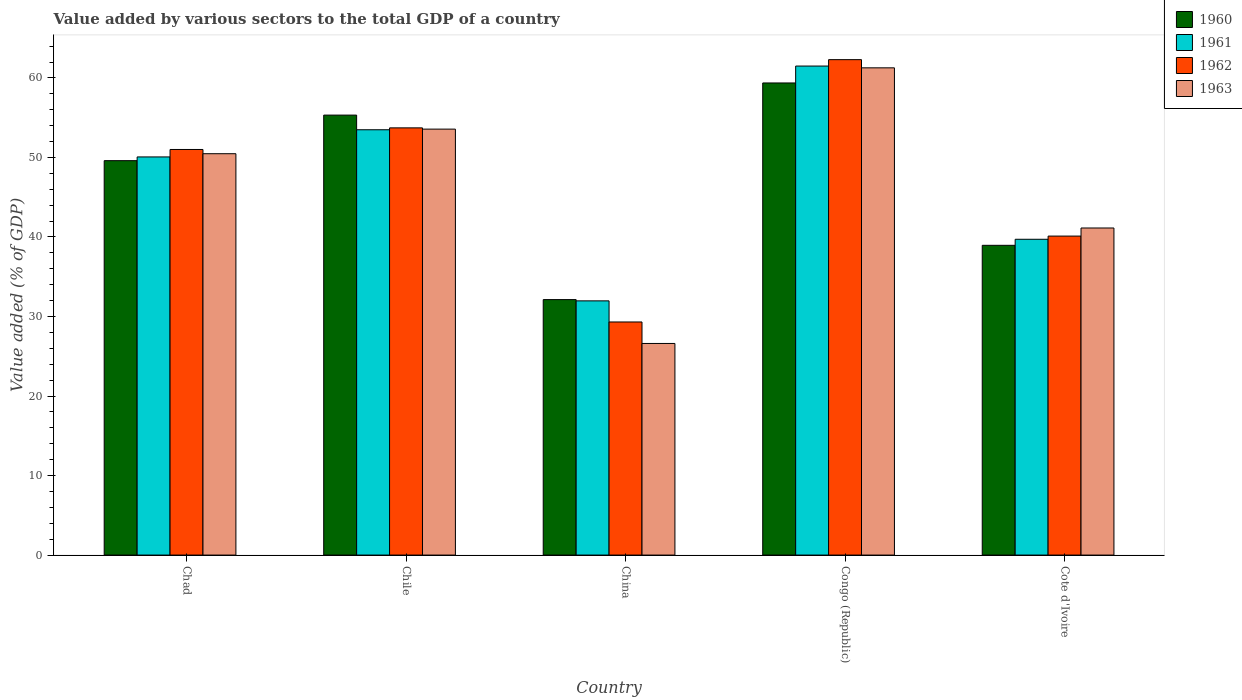How many different coloured bars are there?
Your answer should be compact. 4. How many bars are there on the 5th tick from the right?
Keep it short and to the point. 4. What is the label of the 1st group of bars from the left?
Offer a very short reply. Chad. What is the value added by various sectors to the total GDP in 1961 in China?
Your answer should be compact. 31.97. Across all countries, what is the maximum value added by various sectors to the total GDP in 1961?
Offer a very short reply. 61.5. Across all countries, what is the minimum value added by various sectors to the total GDP in 1961?
Give a very brief answer. 31.97. In which country was the value added by various sectors to the total GDP in 1962 maximum?
Ensure brevity in your answer.  Congo (Republic). What is the total value added by various sectors to the total GDP in 1960 in the graph?
Keep it short and to the point. 235.38. What is the difference between the value added by various sectors to the total GDP in 1960 in China and that in Congo (Republic)?
Your response must be concise. -27.24. What is the difference between the value added by various sectors to the total GDP in 1963 in China and the value added by various sectors to the total GDP in 1961 in Cote d'Ivoire?
Provide a succinct answer. -13.1. What is the average value added by various sectors to the total GDP in 1960 per country?
Provide a succinct answer. 47.08. What is the difference between the value added by various sectors to the total GDP of/in 1960 and value added by various sectors to the total GDP of/in 1963 in Chad?
Give a very brief answer. -0.88. What is the ratio of the value added by various sectors to the total GDP in 1961 in Chile to that in Cote d'Ivoire?
Your answer should be compact. 1.35. Is the value added by various sectors to the total GDP in 1960 in Chad less than that in Congo (Republic)?
Your response must be concise. Yes. What is the difference between the highest and the second highest value added by various sectors to the total GDP in 1960?
Ensure brevity in your answer.  -9.77. What is the difference between the highest and the lowest value added by various sectors to the total GDP in 1962?
Provide a short and direct response. 32.99. Is it the case that in every country, the sum of the value added by various sectors to the total GDP in 1963 and value added by various sectors to the total GDP in 1960 is greater than the sum of value added by various sectors to the total GDP in 1962 and value added by various sectors to the total GDP in 1961?
Make the answer very short. No. What does the 4th bar from the right in China represents?
Your answer should be compact. 1960. Is it the case that in every country, the sum of the value added by various sectors to the total GDP in 1962 and value added by various sectors to the total GDP in 1961 is greater than the value added by various sectors to the total GDP in 1960?
Keep it short and to the point. Yes. Are all the bars in the graph horizontal?
Keep it short and to the point. No. Where does the legend appear in the graph?
Provide a short and direct response. Top right. How many legend labels are there?
Keep it short and to the point. 4. How are the legend labels stacked?
Your answer should be compact. Vertical. What is the title of the graph?
Provide a succinct answer. Value added by various sectors to the total GDP of a country. Does "2006" appear as one of the legend labels in the graph?
Your answer should be compact. No. What is the label or title of the Y-axis?
Your answer should be compact. Value added (% of GDP). What is the Value added (% of GDP) of 1960 in Chad?
Ensure brevity in your answer.  49.6. What is the Value added (% of GDP) in 1961 in Chad?
Your answer should be very brief. 50.07. What is the Value added (% of GDP) in 1962 in Chad?
Provide a succinct answer. 51.01. What is the Value added (% of GDP) of 1963 in Chad?
Your answer should be very brief. 50.47. What is the Value added (% of GDP) in 1960 in Chile?
Your answer should be very brief. 55.33. What is the Value added (% of GDP) of 1961 in Chile?
Offer a terse response. 53.49. What is the Value added (% of GDP) in 1962 in Chile?
Make the answer very short. 53.72. What is the Value added (% of GDP) in 1963 in Chile?
Offer a very short reply. 53.57. What is the Value added (% of GDP) in 1960 in China?
Your answer should be very brief. 32.13. What is the Value added (% of GDP) in 1961 in China?
Your response must be concise. 31.97. What is the Value added (% of GDP) in 1962 in China?
Offer a terse response. 29.31. What is the Value added (% of GDP) of 1963 in China?
Provide a short and direct response. 26.61. What is the Value added (% of GDP) in 1960 in Congo (Republic)?
Offer a very short reply. 59.37. What is the Value added (% of GDP) in 1961 in Congo (Republic)?
Give a very brief answer. 61.5. What is the Value added (% of GDP) in 1962 in Congo (Republic)?
Your answer should be compact. 62.3. What is the Value added (% of GDP) in 1963 in Congo (Republic)?
Provide a short and direct response. 61.27. What is the Value added (% of GDP) in 1960 in Cote d'Ivoire?
Provide a short and direct response. 38.95. What is the Value added (% of GDP) in 1961 in Cote d'Ivoire?
Give a very brief answer. 39.71. What is the Value added (% of GDP) of 1962 in Cote d'Ivoire?
Your answer should be compact. 40.11. What is the Value added (% of GDP) in 1963 in Cote d'Ivoire?
Provide a succinct answer. 41.13. Across all countries, what is the maximum Value added (% of GDP) of 1960?
Your answer should be compact. 59.37. Across all countries, what is the maximum Value added (% of GDP) in 1961?
Provide a short and direct response. 61.5. Across all countries, what is the maximum Value added (% of GDP) of 1962?
Give a very brief answer. 62.3. Across all countries, what is the maximum Value added (% of GDP) of 1963?
Keep it short and to the point. 61.27. Across all countries, what is the minimum Value added (% of GDP) of 1960?
Offer a terse response. 32.13. Across all countries, what is the minimum Value added (% of GDP) of 1961?
Offer a very short reply. 31.97. Across all countries, what is the minimum Value added (% of GDP) in 1962?
Your answer should be compact. 29.31. Across all countries, what is the minimum Value added (% of GDP) of 1963?
Your response must be concise. 26.61. What is the total Value added (% of GDP) in 1960 in the graph?
Ensure brevity in your answer.  235.38. What is the total Value added (% of GDP) in 1961 in the graph?
Make the answer very short. 236.73. What is the total Value added (% of GDP) in 1962 in the graph?
Make the answer very short. 236.46. What is the total Value added (% of GDP) of 1963 in the graph?
Provide a succinct answer. 233.06. What is the difference between the Value added (% of GDP) of 1960 in Chad and that in Chile?
Make the answer very short. -5.73. What is the difference between the Value added (% of GDP) in 1961 in Chad and that in Chile?
Provide a short and direct response. -3.42. What is the difference between the Value added (% of GDP) of 1962 in Chad and that in Chile?
Your answer should be compact. -2.72. What is the difference between the Value added (% of GDP) in 1963 in Chad and that in Chile?
Provide a succinct answer. -3.09. What is the difference between the Value added (% of GDP) of 1960 in Chad and that in China?
Give a very brief answer. 17.47. What is the difference between the Value added (% of GDP) in 1961 in Chad and that in China?
Your answer should be very brief. 18.1. What is the difference between the Value added (% of GDP) in 1962 in Chad and that in China?
Give a very brief answer. 21.69. What is the difference between the Value added (% of GDP) in 1963 in Chad and that in China?
Ensure brevity in your answer.  23.86. What is the difference between the Value added (% of GDP) in 1960 in Chad and that in Congo (Republic)?
Make the answer very short. -9.77. What is the difference between the Value added (% of GDP) in 1961 in Chad and that in Congo (Republic)?
Give a very brief answer. -11.43. What is the difference between the Value added (% of GDP) in 1962 in Chad and that in Congo (Republic)?
Your answer should be compact. -11.3. What is the difference between the Value added (% of GDP) of 1963 in Chad and that in Congo (Republic)?
Offer a terse response. -10.8. What is the difference between the Value added (% of GDP) in 1960 in Chad and that in Cote d'Ivoire?
Ensure brevity in your answer.  10.65. What is the difference between the Value added (% of GDP) in 1961 in Chad and that in Cote d'Ivoire?
Ensure brevity in your answer.  10.35. What is the difference between the Value added (% of GDP) in 1962 in Chad and that in Cote d'Ivoire?
Ensure brevity in your answer.  10.89. What is the difference between the Value added (% of GDP) of 1963 in Chad and that in Cote d'Ivoire?
Provide a succinct answer. 9.34. What is the difference between the Value added (% of GDP) in 1960 in Chile and that in China?
Your response must be concise. 23.2. What is the difference between the Value added (% of GDP) of 1961 in Chile and that in China?
Provide a short and direct response. 21.52. What is the difference between the Value added (% of GDP) in 1962 in Chile and that in China?
Your answer should be very brief. 24.41. What is the difference between the Value added (% of GDP) of 1963 in Chile and that in China?
Your answer should be compact. 26.96. What is the difference between the Value added (% of GDP) of 1960 in Chile and that in Congo (Republic)?
Offer a terse response. -4.04. What is the difference between the Value added (% of GDP) in 1961 in Chile and that in Congo (Republic)?
Give a very brief answer. -8.01. What is the difference between the Value added (% of GDP) in 1962 in Chile and that in Congo (Republic)?
Offer a very short reply. -8.58. What is the difference between the Value added (% of GDP) in 1963 in Chile and that in Congo (Republic)?
Ensure brevity in your answer.  -7.71. What is the difference between the Value added (% of GDP) of 1960 in Chile and that in Cote d'Ivoire?
Offer a terse response. 16.38. What is the difference between the Value added (% of GDP) in 1961 in Chile and that in Cote d'Ivoire?
Make the answer very short. 13.77. What is the difference between the Value added (% of GDP) in 1962 in Chile and that in Cote d'Ivoire?
Provide a succinct answer. 13.61. What is the difference between the Value added (% of GDP) in 1963 in Chile and that in Cote d'Ivoire?
Make the answer very short. 12.43. What is the difference between the Value added (% of GDP) in 1960 in China and that in Congo (Republic)?
Keep it short and to the point. -27.24. What is the difference between the Value added (% of GDP) of 1961 in China and that in Congo (Republic)?
Make the answer very short. -29.53. What is the difference between the Value added (% of GDP) in 1962 in China and that in Congo (Republic)?
Your response must be concise. -32.99. What is the difference between the Value added (% of GDP) in 1963 in China and that in Congo (Republic)?
Ensure brevity in your answer.  -34.66. What is the difference between the Value added (% of GDP) in 1960 in China and that in Cote d'Ivoire?
Provide a short and direct response. -6.83. What is the difference between the Value added (% of GDP) of 1961 in China and that in Cote d'Ivoire?
Give a very brief answer. -7.75. What is the difference between the Value added (% of GDP) of 1962 in China and that in Cote d'Ivoire?
Give a very brief answer. -10.8. What is the difference between the Value added (% of GDP) in 1963 in China and that in Cote d'Ivoire?
Your response must be concise. -14.52. What is the difference between the Value added (% of GDP) of 1960 in Congo (Republic) and that in Cote d'Ivoire?
Provide a short and direct response. 20.42. What is the difference between the Value added (% of GDP) in 1961 in Congo (Republic) and that in Cote d'Ivoire?
Provide a short and direct response. 21.78. What is the difference between the Value added (% of GDP) of 1962 in Congo (Republic) and that in Cote d'Ivoire?
Your response must be concise. 22.19. What is the difference between the Value added (% of GDP) of 1963 in Congo (Republic) and that in Cote d'Ivoire?
Keep it short and to the point. 20.14. What is the difference between the Value added (% of GDP) of 1960 in Chad and the Value added (% of GDP) of 1961 in Chile?
Your response must be concise. -3.89. What is the difference between the Value added (% of GDP) in 1960 in Chad and the Value added (% of GDP) in 1962 in Chile?
Make the answer very short. -4.13. What is the difference between the Value added (% of GDP) of 1960 in Chad and the Value added (% of GDP) of 1963 in Chile?
Your answer should be very brief. -3.97. What is the difference between the Value added (% of GDP) of 1961 in Chad and the Value added (% of GDP) of 1962 in Chile?
Your answer should be compact. -3.66. What is the difference between the Value added (% of GDP) in 1961 in Chad and the Value added (% of GDP) in 1963 in Chile?
Make the answer very short. -3.5. What is the difference between the Value added (% of GDP) in 1962 in Chad and the Value added (% of GDP) in 1963 in Chile?
Provide a succinct answer. -2.56. What is the difference between the Value added (% of GDP) of 1960 in Chad and the Value added (% of GDP) of 1961 in China?
Keep it short and to the point. 17.63. What is the difference between the Value added (% of GDP) of 1960 in Chad and the Value added (% of GDP) of 1962 in China?
Offer a very short reply. 20.29. What is the difference between the Value added (% of GDP) of 1960 in Chad and the Value added (% of GDP) of 1963 in China?
Ensure brevity in your answer.  22.99. What is the difference between the Value added (% of GDP) in 1961 in Chad and the Value added (% of GDP) in 1962 in China?
Offer a very short reply. 20.76. What is the difference between the Value added (% of GDP) in 1961 in Chad and the Value added (% of GDP) in 1963 in China?
Your response must be concise. 23.46. What is the difference between the Value added (% of GDP) in 1962 in Chad and the Value added (% of GDP) in 1963 in China?
Make the answer very short. 24.39. What is the difference between the Value added (% of GDP) of 1960 in Chad and the Value added (% of GDP) of 1961 in Congo (Republic)?
Offer a terse response. -11.9. What is the difference between the Value added (% of GDP) of 1960 in Chad and the Value added (% of GDP) of 1962 in Congo (Republic)?
Keep it short and to the point. -12.7. What is the difference between the Value added (% of GDP) in 1960 in Chad and the Value added (% of GDP) in 1963 in Congo (Republic)?
Make the answer very short. -11.67. What is the difference between the Value added (% of GDP) of 1961 in Chad and the Value added (% of GDP) of 1962 in Congo (Republic)?
Offer a terse response. -12.23. What is the difference between the Value added (% of GDP) of 1961 in Chad and the Value added (% of GDP) of 1963 in Congo (Republic)?
Your answer should be compact. -11.2. What is the difference between the Value added (% of GDP) of 1962 in Chad and the Value added (% of GDP) of 1963 in Congo (Republic)?
Keep it short and to the point. -10.27. What is the difference between the Value added (% of GDP) in 1960 in Chad and the Value added (% of GDP) in 1961 in Cote d'Ivoire?
Provide a succinct answer. 9.88. What is the difference between the Value added (% of GDP) of 1960 in Chad and the Value added (% of GDP) of 1962 in Cote d'Ivoire?
Your response must be concise. 9.48. What is the difference between the Value added (% of GDP) in 1960 in Chad and the Value added (% of GDP) in 1963 in Cote d'Ivoire?
Provide a short and direct response. 8.47. What is the difference between the Value added (% of GDP) of 1961 in Chad and the Value added (% of GDP) of 1962 in Cote d'Ivoire?
Give a very brief answer. 9.96. What is the difference between the Value added (% of GDP) in 1961 in Chad and the Value added (% of GDP) in 1963 in Cote d'Ivoire?
Your response must be concise. 8.94. What is the difference between the Value added (% of GDP) in 1962 in Chad and the Value added (% of GDP) in 1963 in Cote d'Ivoire?
Keep it short and to the point. 9.87. What is the difference between the Value added (% of GDP) in 1960 in Chile and the Value added (% of GDP) in 1961 in China?
Make the answer very short. 23.36. What is the difference between the Value added (% of GDP) of 1960 in Chile and the Value added (% of GDP) of 1962 in China?
Your response must be concise. 26.02. What is the difference between the Value added (% of GDP) of 1960 in Chile and the Value added (% of GDP) of 1963 in China?
Provide a short and direct response. 28.72. What is the difference between the Value added (% of GDP) in 1961 in Chile and the Value added (% of GDP) in 1962 in China?
Your answer should be very brief. 24.17. What is the difference between the Value added (% of GDP) in 1961 in Chile and the Value added (% of GDP) in 1963 in China?
Make the answer very short. 26.87. What is the difference between the Value added (% of GDP) in 1962 in Chile and the Value added (% of GDP) in 1963 in China?
Keep it short and to the point. 27.11. What is the difference between the Value added (% of GDP) in 1960 in Chile and the Value added (% of GDP) in 1961 in Congo (Republic)?
Your answer should be very brief. -6.17. What is the difference between the Value added (% of GDP) of 1960 in Chile and the Value added (% of GDP) of 1962 in Congo (Republic)?
Your answer should be compact. -6.97. What is the difference between the Value added (% of GDP) in 1960 in Chile and the Value added (% of GDP) in 1963 in Congo (Republic)?
Keep it short and to the point. -5.94. What is the difference between the Value added (% of GDP) of 1961 in Chile and the Value added (% of GDP) of 1962 in Congo (Republic)?
Offer a very short reply. -8.82. What is the difference between the Value added (% of GDP) of 1961 in Chile and the Value added (% of GDP) of 1963 in Congo (Republic)?
Offer a very short reply. -7.79. What is the difference between the Value added (% of GDP) in 1962 in Chile and the Value added (% of GDP) in 1963 in Congo (Republic)?
Make the answer very short. -7.55. What is the difference between the Value added (% of GDP) of 1960 in Chile and the Value added (% of GDP) of 1961 in Cote d'Ivoire?
Offer a terse response. 15.61. What is the difference between the Value added (% of GDP) of 1960 in Chile and the Value added (% of GDP) of 1962 in Cote d'Ivoire?
Make the answer very short. 15.21. What is the difference between the Value added (% of GDP) in 1960 in Chile and the Value added (% of GDP) in 1963 in Cote d'Ivoire?
Keep it short and to the point. 14.2. What is the difference between the Value added (% of GDP) of 1961 in Chile and the Value added (% of GDP) of 1962 in Cote d'Ivoire?
Your answer should be compact. 13.37. What is the difference between the Value added (% of GDP) of 1961 in Chile and the Value added (% of GDP) of 1963 in Cote d'Ivoire?
Your answer should be compact. 12.35. What is the difference between the Value added (% of GDP) of 1962 in Chile and the Value added (% of GDP) of 1963 in Cote d'Ivoire?
Your answer should be very brief. 12.59. What is the difference between the Value added (% of GDP) of 1960 in China and the Value added (% of GDP) of 1961 in Congo (Republic)?
Provide a succinct answer. -29.37. What is the difference between the Value added (% of GDP) in 1960 in China and the Value added (% of GDP) in 1962 in Congo (Republic)?
Provide a short and direct response. -30.18. What is the difference between the Value added (% of GDP) of 1960 in China and the Value added (% of GDP) of 1963 in Congo (Republic)?
Ensure brevity in your answer.  -29.15. What is the difference between the Value added (% of GDP) in 1961 in China and the Value added (% of GDP) in 1962 in Congo (Republic)?
Make the answer very short. -30.34. What is the difference between the Value added (% of GDP) in 1961 in China and the Value added (% of GDP) in 1963 in Congo (Republic)?
Keep it short and to the point. -29.31. What is the difference between the Value added (% of GDP) in 1962 in China and the Value added (% of GDP) in 1963 in Congo (Republic)?
Offer a terse response. -31.96. What is the difference between the Value added (% of GDP) of 1960 in China and the Value added (% of GDP) of 1961 in Cote d'Ivoire?
Your answer should be very brief. -7.59. What is the difference between the Value added (% of GDP) in 1960 in China and the Value added (% of GDP) in 1962 in Cote d'Ivoire?
Your answer should be very brief. -7.99. What is the difference between the Value added (% of GDP) in 1960 in China and the Value added (% of GDP) in 1963 in Cote d'Ivoire?
Offer a terse response. -9.01. What is the difference between the Value added (% of GDP) of 1961 in China and the Value added (% of GDP) of 1962 in Cote d'Ivoire?
Offer a terse response. -8.15. What is the difference between the Value added (% of GDP) in 1961 in China and the Value added (% of GDP) in 1963 in Cote d'Ivoire?
Make the answer very short. -9.17. What is the difference between the Value added (% of GDP) of 1962 in China and the Value added (% of GDP) of 1963 in Cote d'Ivoire?
Provide a succinct answer. -11.82. What is the difference between the Value added (% of GDP) of 1960 in Congo (Republic) and the Value added (% of GDP) of 1961 in Cote d'Ivoire?
Your answer should be very brief. 19.66. What is the difference between the Value added (% of GDP) in 1960 in Congo (Republic) and the Value added (% of GDP) in 1962 in Cote d'Ivoire?
Your response must be concise. 19.26. What is the difference between the Value added (% of GDP) in 1960 in Congo (Republic) and the Value added (% of GDP) in 1963 in Cote d'Ivoire?
Offer a terse response. 18.24. What is the difference between the Value added (% of GDP) in 1961 in Congo (Republic) and the Value added (% of GDP) in 1962 in Cote d'Ivoire?
Give a very brief answer. 21.38. What is the difference between the Value added (% of GDP) in 1961 in Congo (Republic) and the Value added (% of GDP) in 1963 in Cote d'Ivoire?
Your answer should be compact. 20.36. What is the difference between the Value added (% of GDP) in 1962 in Congo (Republic) and the Value added (% of GDP) in 1963 in Cote d'Ivoire?
Your answer should be very brief. 21.17. What is the average Value added (% of GDP) of 1960 per country?
Ensure brevity in your answer.  47.08. What is the average Value added (% of GDP) of 1961 per country?
Your response must be concise. 47.35. What is the average Value added (% of GDP) of 1962 per country?
Give a very brief answer. 47.29. What is the average Value added (% of GDP) of 1963 per country?
Offer a terse response. 46.61. What is the difference between the Value added (% of GDP) of 1960 and Value added (% of GDP) of 1961 in Chad?
Offer a very short reply. -0.47. What is the difference between the Value added (% of GDP) in 1960 and Value added (% of GDP) in 1962 in Chad?
Provide a short and direct response. -1.41. What is the difference between the Value added (% of GDP) of 1960 and Value added (% of GDP) of 1963 in Chad?
Make the answer very short. -0.88. What is the difference between the Value added (% of GDP) of 1961 and Value added (% of GDP) of 1962 in Chad?
Provide a short and direct response. -0.94. What is the difference between the Value added (% of GDP) of 1961 and Value added (% of GDP) of 1963 in Chad?
Your response must be concise. -0.41. What is the difference between the Value added (% of GDP) in 1962 and Value added (% of GDP) in 1963 in Chad?
Your answer should be compact. 0.53. What is the difference between the Value added (% of GDP) of 1960 and Value added (% of GDP) of 1961 in Chile?
Provide a succinct answer. 1.84. What is the difference between the Value added (% of GDP) of 1960 and Value added (% of GDP) of 1962 in Chile?
Make the answer very short. 1.6. What is the difference between the Value added (% of GDP) of 1960 and Value added (% of GDP) of 1963 in Chile?
Your response must be concise. 1.76. What is the difference between the Value added (% of GDP) of 1961 and Value added (% of GDP) of 1962 in Chile?
Your response must be concise. -0.24. What is the difference between the Value added (% of GDP) of 1961 and Value added (% of GDP) of 1963 in Chile?
Your response must be concise. -0.08. What is the difference between the Value added (% of GDP) of 1962 and Value added (% of GDP) of 1963 in Chile?
Offer a very short reply. 0.16. What is the difference between the Value added (% of GDP) in 1960 and Value added (% of GDP) in 1961 in China?
Your answer should be very brief. 0.16. What is the difference between the Value added (% of GDP) in 1960 and Value added (% of GDP) in 1962 in China?
Your answer should be compact. 2.81. What is the difference between the Value added (% of GDP) in 1960 and Value added (% of GDP) in 1963 in China?
Your response must be concise. 5.52. What is the difference between the Value added (% of GDP) in 1961 and Value added (% of GDP) in 1962 in China?
Provide a succinct answer. 2.65. What is the difference between the Value added (% of GDP) in 1961 and Value added (% of GDP) in 1963 in China?
Your answer should be very brief. 5.36. What is the difference between the Value added (% of GDP) of 1962 and Value added (% of GDP) of 1963 in China?
Your response must be concise. 2.7. What is the difference between the Value added (% of GDP) in 1960 and Value added (% of GDP) in 1961 in Congo (Republic)?
Provide a short and direct response. -2.13. What is the difference between the Value added (% of GDP) in 1960 and Value added (% of GDP) in 1962 in Congo (Republic)?
Give a very brief answer. -2.93. What is the difference between the Value added (% of GDP) of 1960 and Value added (% of GDP) of 1963 in Congo (Republic)?
Keep it short and to the point. -1.9. What is the difference between the Value added (% of GDP) of 1961 and Value added (% of GDP) of 1962 in Congo (Republic)?
Your response must be concise. -0.81. What is the difference between the Value added (% of GDP) of 1961 and Value added (% of GDP) of 1963 in Congo (Republic)?
Your answer should be compact. 0.22. What is the difference between the Value added (% of GDP) in 1962 and Value added (% of GDP) in 1963 in Congo (Republic)?
Provide a short and direct response. 1.03. What is the difference between the Value added (% of GDP) of 1960 and Value added (% of GDP) of 1961 in Cote d'Ivoire?
Keep it short and to the point. -0.76. What is the difference between the Value added (% of GDP) of 1960 and Value added (% of GDP) of 1962 in Cote d'Ivoire?
Your answer should be compact. -1.16. What is the difference between the Value added (% of GDP) in 1960 and Value added (% of GDP) in 1963 in Cote d'Ivoire?
Make the answer very short. -2.18. What is the difference between the Value added (% of GDP) of 1961 and Value added (% of GDP) of 1962 in Cote d'Ivoire?
Keep it short and to the point. -0.4. What is the difference between the Value added (% of GDP) of 1961 and Value added (% of GDP) of 1963 in Cote d'Ivoire?
Keep it short and to the point. -1.42. What is the difference between the Value added (% of GDP) of 1962 and Value added (% of GDP) of 1963 in Cote d'Ivoire?
Provide a succinct answer. -1.02. What is the ratio of the Value added (% of GDP) in 1960 in Chad to that in Chile?
Your response must be concise. 0.9. What is the ratio of the Value added (% of GDP) of 1961 in Chad to that in Chile?
Your response must be concise. 0.94. What is the ratio of the Value added (% of GDP) in 1962 in Chad to that in Chile?
Keep it short and to the point. 0.95. What is the ratio of the Value added (% of GDP) in 1963 in Chad to that in Chile?
Keep it short and to the point. 0.94. What is the ratio of the Value added (% of GDP) in 1960 in Chad to that in China?
Make the answer very short. 1.54. What is the ratio of the Value added (% of GDP) of 1961 in Chad to that in China?
Offer a very short reply. 1.57. What is the ratio of the Value added (% of GDP) in 1962 in Chad to that in China?
Keep it short and to the point. 1.74. What is the ratio of the Value added (% of GDP) of 1963 in Chad to that in China?
Provide a succinct answer. 1.9. What is the ratio of the Value added (% of GDP) of 1960 in Chad to that in Congo (Republic)?
Offer a very short reply. 0.84. What is the ratio of the Value added (% of GDP) in 1961 in Chad to that in Congo (Republic)?
Your answer should be very brief. 0.81. What is the ratio of the Value added (% of GDP) in 1962 in Chad to that in Congo (Republic)?
Your response must be concise. 0.82. What is the ratio of the Value added (% of GDP) of 1963 in Chad to that in Congo (Republic)?
Your answer should be very brief. 0.82. What is the ratio of the Value added (% of GDP) in 1960 in Chad to that in Cote d'Ivoire?
Offer a terse response. 1.27. What is the ratio of the Value added (% of GDP) in 1961 in Chad to that in Cote d'Ivoire?
Provide a short and direct response. 1.26. What is the ratio of the Value added (% of GDP) in 1962 in Chad to that in Cote d'Ivoire?
Keep it short and to the point. 1.27. What is the ratio of the Value added (% of GDP) in 1963 in Chad to that in Cote d'Ivoire?
Provide a short and direct response. 1.23. What is the ratio of the Value added (% of GDP) in 1960 in Chile to that in China?
Ensure brevity in your answer.  1.72. What is the ratio of the Value added (% of GDP) of 1961 in Chile to that in China?
Give a very brief answer. 1.67. What is the ratio of the Value added (% of GDP) in 1962 in Chile to that in China?
Offer a terse response. 1.83. What is the ratio of the Value added (% of GDP) of 1963 in Chile to that in China?
Provide a succinct answer. 2.01. What is the ratio of the Value added (% of GDP) in 1960 in Chile to that in Congo (Republic)?
Keep it short and to the point. 0.93. What is the ratio of the Value added (% of GDP) in 1961 in Chile to that in Congo (Republic)?
Ensure brevity in your answer.  0.87. What is the ratio of the Value added (% of GDP) in 1962 in Chile to that in Congo (Republic)?
Provide a short and direct response. 0.86. What is the ratio of the Value added (% of GDP) of 1963 in Chile to that in Congo (Republic)?
Your response must be concise. 0.87. What is the ratio of the Value added (% of GDP) in 1960 in Chile to that in Cote d'Ivoire?
Your answer should be very brief. 1.42. What is the ratio of the Value added (% of GDP) of 1961 in Chile to that in Cote d'Ivoire?
Offer a terse response. 1.35. What is the ratio of the Value added (% of GDP) in 1962 in Chile to that in Cote d'Ivoire?
Provide a short and direct response. 1.34. What is the ratio of the Value added (% of GDP) of 1963 in Chile to that in Cote d'Ivoire?
Offer a terse response. 1.3. What is the ratio of the Value added (% of GDP) in 1960 in China to that in Congo (Republic)?
Give a very brief answer. 0.54. What is the ratio of the Value added (% of GDP) in 1961 in China to that in Congo (Republic)?
Provide a succinct answer. 0.52. What is the ratio of the Value added (% of GDP) in 1962 in China to that in Congo (Republic)?
Offer a terse response. 0.47. What is the ratio of the Value added (% of GDP) of 1963 in China to that in Congo (Republic)?
Your answer should be very brief. 0.43. What is the ratio of the Value added (% of GDP) of 1960 in China to that in Cote d'Ivoire?
Make the answer very short. 0.82. What is the ratio of the Value added (% of GDP) in 1961 in China to that in Cote d'Ivoire?
Your answer should be compact. 0.8. What is the ratio of the Value added (% of GDP) in 1962 in China to that in Cote d'Ivoire?
Ensure brevity in your answer.  0.73. What is the ratio of the Value added (% of GDP) of 1963 in China to that in Cote d'Ivoire?
Offer a terse response. 0.65. What is the ratio of the Value added (% of GDP) in 1960 in Congo (Republic) to that in Cote d'Ivoire?
Offer a terse response. 1.52. What is the ratio of the Value added (% of GDP) in 1961 in Congo (Republic) to that in Cote d'Ivoire?
Provide a succinct answer. 1.55. What is the ratio of the Value added (% of GDP) in 1962 in Congo (Republic) to that in Cote d'Ivoire?
Make the answer very short. 1.55. What is the ratio of the Value added (% of GDP) in 1963 in Congo (Republic) to that in Cote d'Ivoire?
Keep it short and to the point. 1.49. What is the difference between the highest and the second highest Value added (% of GDP) of 1960?
Make the answer very short. 4.04. What is the difference between the highest and the second highest Value added (% of GDP) in 1961?
Offer a terse response. 8.01. What is the difference between the highest and the second highest Value added (% of GDP) of 1962?
Your response must be concise. 8.58. What is the difference between the highest and the second highest Value added (% of GDP) in 1963?
Offer a very short reply. 7.71. What is the difference between the highest and the lowest Value added (% of GDP) in 1960?
Ensure brevity in your answer.  27.24. What is the difference between the highest and the lowest Value added (% of GDP) of 1961?
Provide a succinct answer. 29.53. What is the difference between the highest and the lowest Value added (% of GDP) of 1962?
Make the answer very short. 32.99. What is the difference between the highest and the lowest Value added (% of GDP) of 1963?
Offer a terse response. 34.66. 